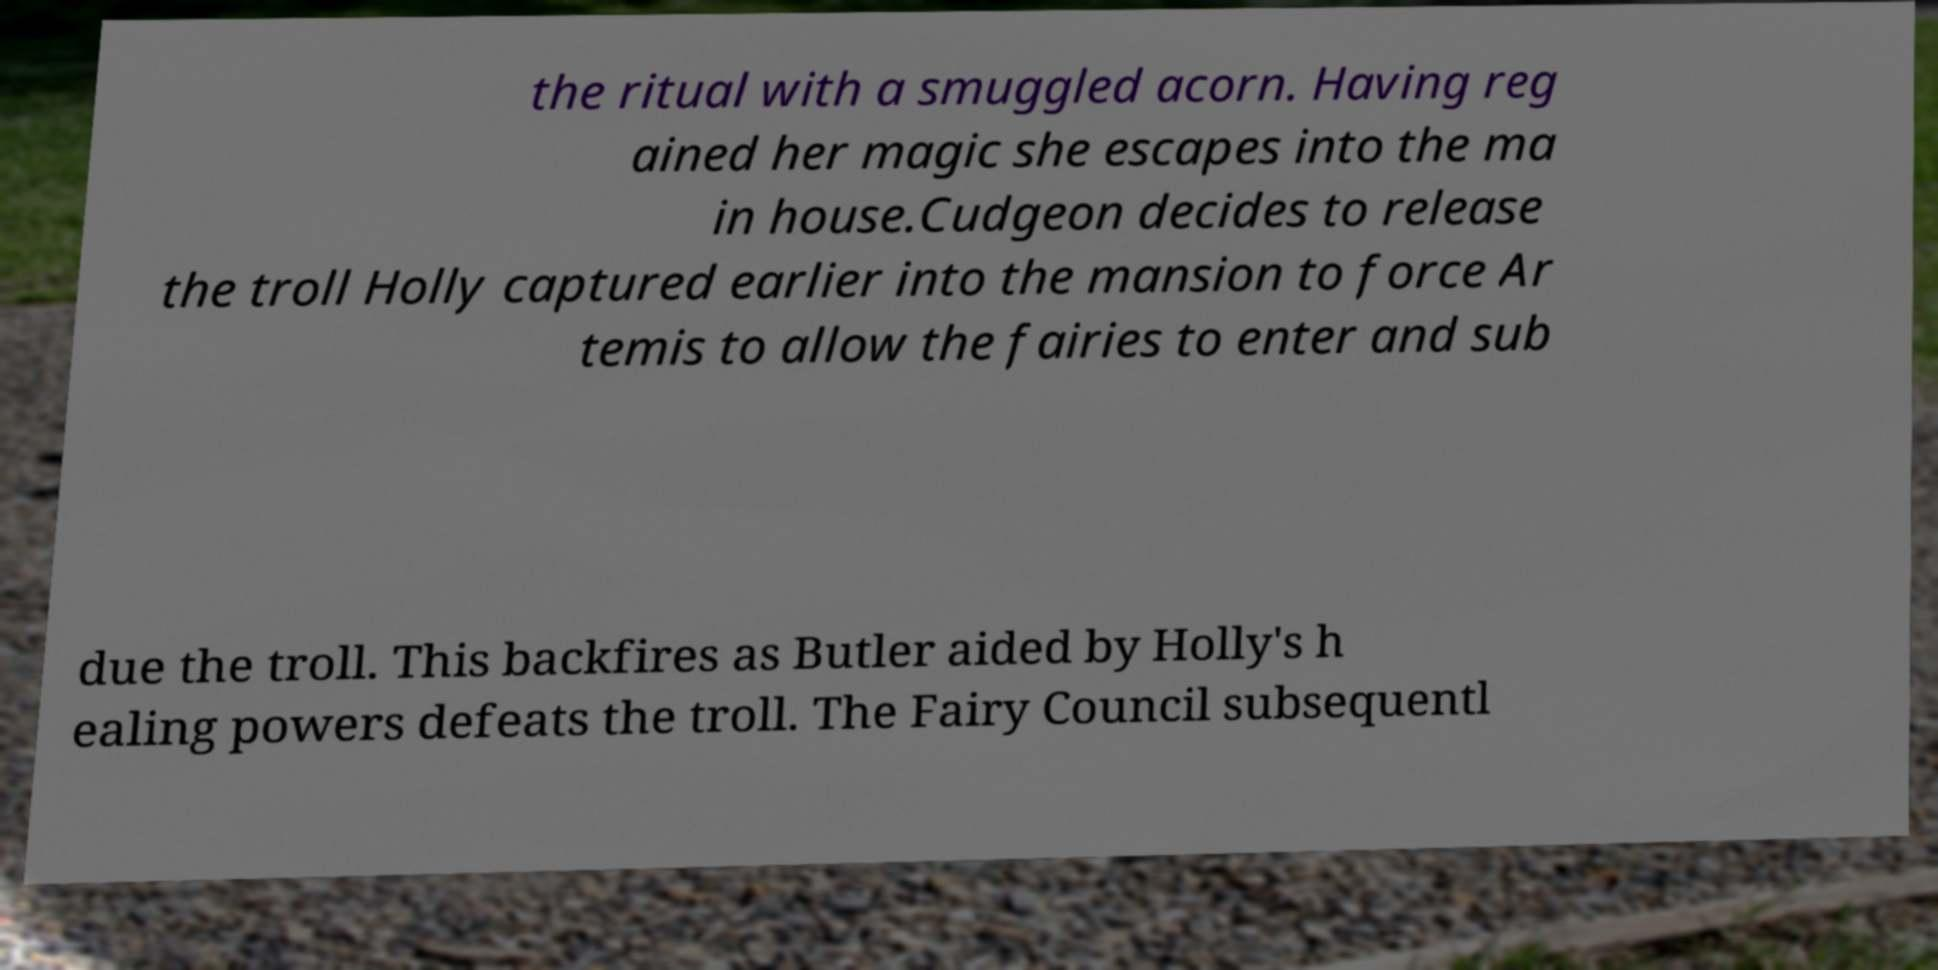Can you read and provide the text displayed in the image?This photo seems to have some interesting text. Can you extract and type it out for me? the ritual with a smuggled acorn. Having reg ained her magic she escapes into the ma in house.Cudgeon decides to release the troll Holly captured earlier into the mansion to force Ar temis to allow the fairies to enter and sub due the troll. This backfires as Butler aided by Holly's h ealing powers defeats the troll. The Fairy Council subsequentl 